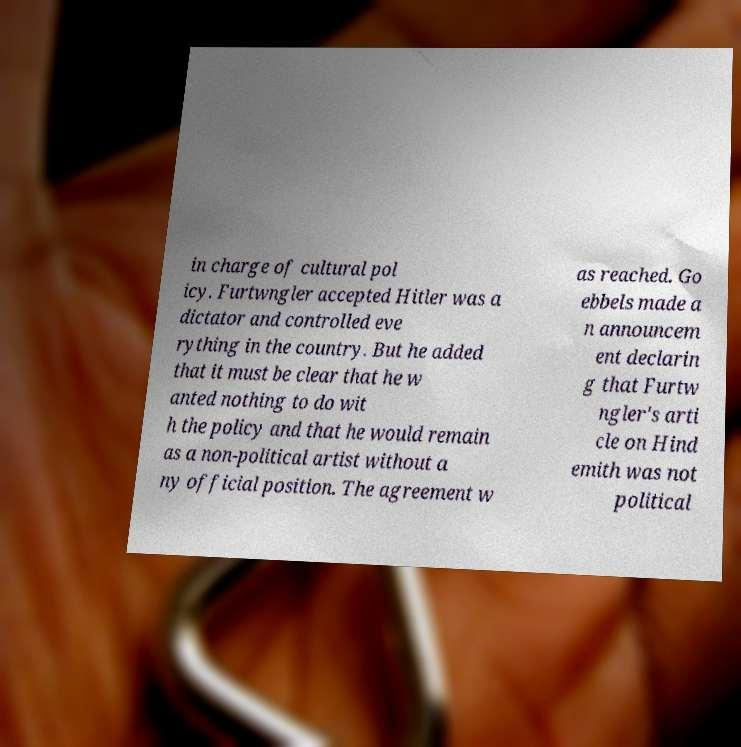For documentation purposes, I need the text within this image transcribed. Could you provide that? in charge of cultural pol icy. Furtwngler accepted Hitler was a dictator and controlled eve rything in the country. But he added that it must be clear that he w anted nothing to do wit h the policy and that he would remain as a non-political artist without a ny official position. The agreement w as reached. Go ebbels made a n announcem ent declarin g that Furtw ngler's arti cle on Hind emith was not political 